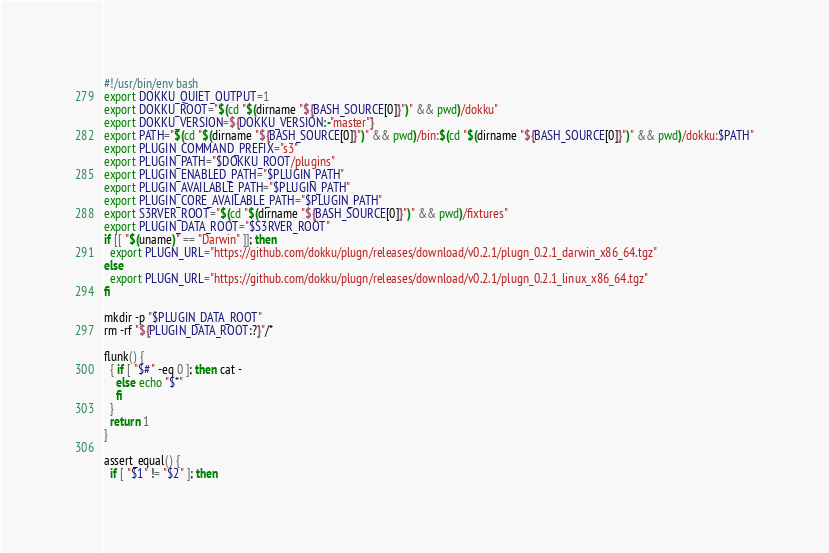Convert code to text. <code><loc_0><loc_0><loc_500><loc_500><_Bash_>#!/usr/bin/env bash
export DOKKU_QUIET_OUTPUT=1
export DOKKU_ROOT="$(cd "$(dirname "${BASH_SOURCE[0]}")" && pwd)/dokku"
export DOKKU_VERSION=${DOKKU_VERSION:-"master"}
export PATH="$(cd "$(dirname "${BASH_SOURCE[0]}")" && pwd)/bin:$(cd "$(dirname "${BASH_SOURCE[0]}")" && pwd)/dokku:$PATH"
export PLUGIN_COMMAND_PREFIX="s3"
export PLUGIN_PATH="$DOKKU_ROOT/plugins"
export PLUGIN_ENABLED_PATH="$PLUGIN_PATH"
export PLUGIN_AVAILABLE_PATH="$PLUGIN_PATH"
export PLUGIN_CORE_AVAILABLE_PATH="$PLUGIN_PATH"
export S3RVER_ROOT="$(cd "$(dirname "${BASH_SOURCE[0]}")" && pwd)/fixtures"
export PLUGIN_DATA_ROOT="$S3RVER_ROOT"
if [[ "$(uname)" == "Darwin" ]]; then
  export PLUGN_URL="https://github.com/dokku/plugn/releases/download/v0.2.1/plugn_0.2.1_darwin_x86_64.tgz"
else
  export PLUGN_URL="https://github.com/dokku/plugn/releases/download/v0.2.1/plugn_0.2.1_linux_x86_64.tgz"
fi

mkdir -p "$PLUGIN_DATA_ROOT"
rm -rf "${PLUGIN_DATA_ROOT:?}"/*

flunk() {
  { if [ "$#" -eq 0 ]; then cat -
    else echo "$*"
    fi
  }
  return 1
}

assert_equal() {
  if [ "$1" != "$2" ]; then</code> 